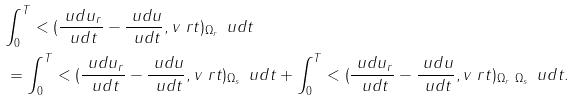Convert formula to latex. <formula><loc_0><loc_0><loc_500><loc_500>& \int _ { 0 } ^ { T } < ( \frac { \ u d u _ { r } } { \ u d t } - \frac { \ u d u } { \ u d t } , v \ r t ) _ { \Omega _ { r } } \, \ u d t \\ & \, = \int _ { 0 } ^ { T } < ( \frac { \ u d u _ { r } } { \ u d t } - \frac { \ u d u } { \ u d t } , v \ r t ) _ { \Omega _ { s } } \, \ u d t + \int _ { 0 } ^ { T } < ( \frac { \ u d u _ { r } } { \ u d t } - \frac { \ u d u } { \ u d t } , v \ r t ) _ { \Omega _ { r } \ \Omega _ { s } } \, \ u d t .</formula> 